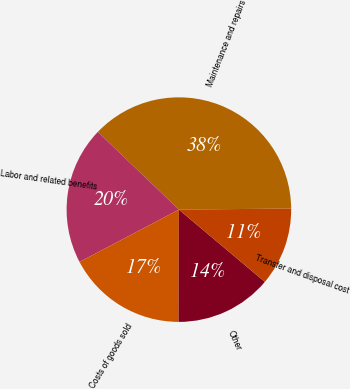Convert chart to OTSL. <chart><loc_0><loc_0><loc_500><loc_500><pie_chart><fcel>Maintenance and repairs<fcel>Labor and related benefits<fcel>Costs of goods sold<fcel>Other<fcel>Transfer and disposal cost<nl><fcel>37.68%<fcel>19.88%<fcel>17.24%<fcel>13.92%<fcel>11.28%<nl></chart> 